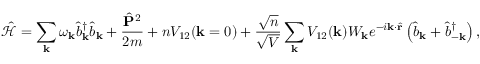<formula> <loc_0><loc_0><loc_500><loc_500>\mathcal { \hat { H } } = \sum _ { k } \omega _ { k } \hat { b } _ { k } ^ { \dagger } \hat { b } _ { k } + \frac { \hat { P } ^ { 2 } } { 2 m } + n V _ { 1 2 } ( k = 0 ) + \frac { \sqrt { n } } { \sqrt { V } } \sum _ { k } V _ { 1 2 } ( k ) W _ { k } e ^ { - i k \cdot \hat { r } } \left ( \hat { b } _ { k } + \hat { b } _ { - k } ^ { \dagger } \right ) ,</formula> 